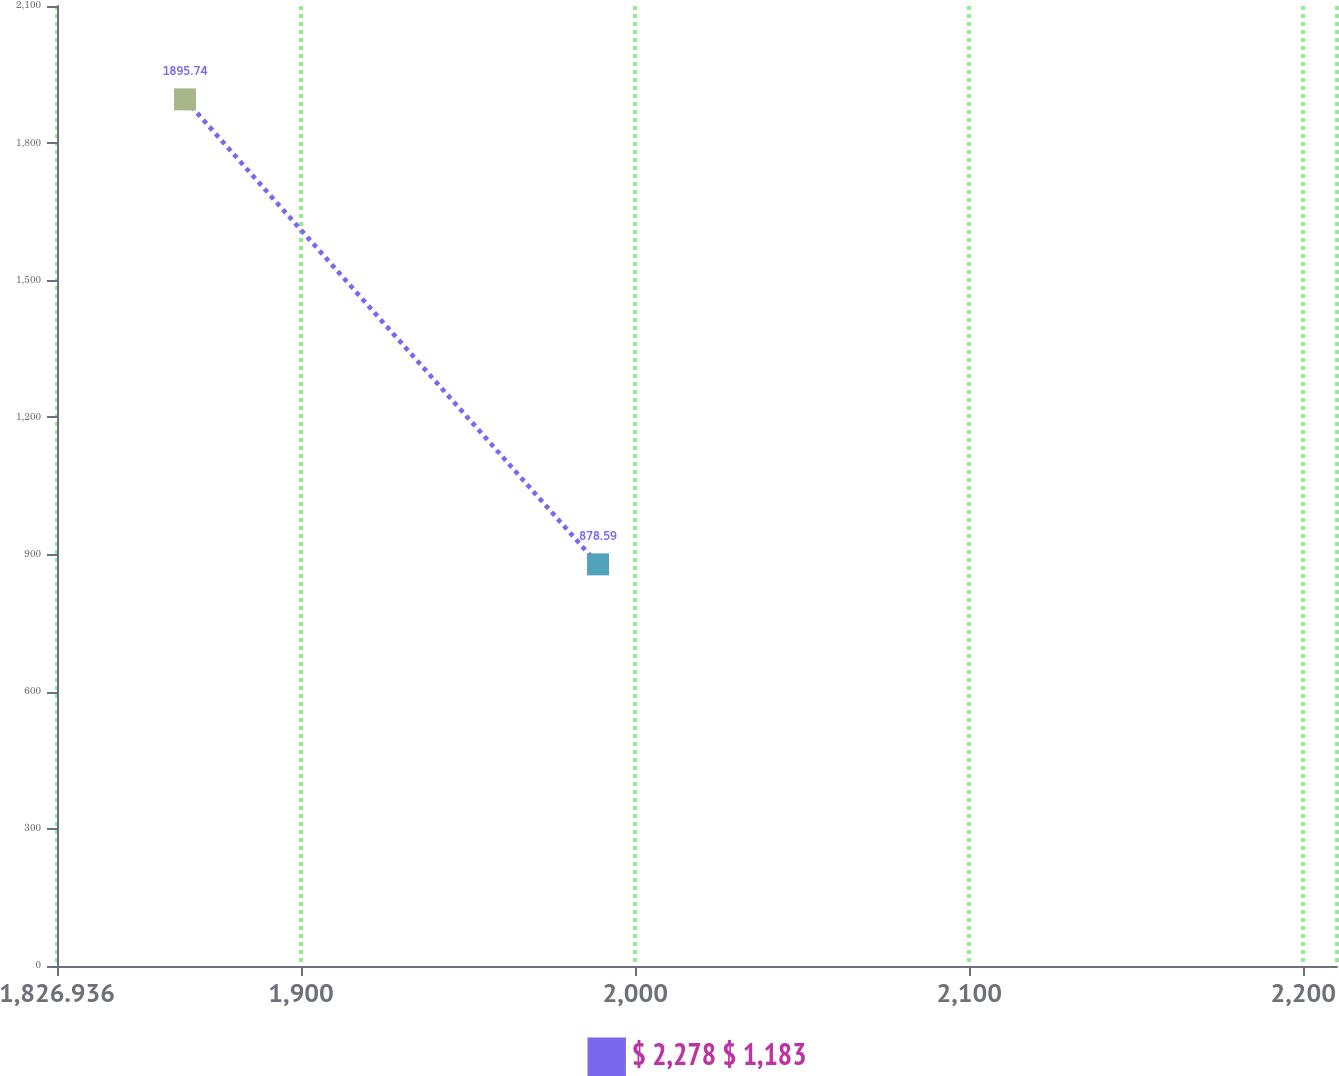<chart> <loc_0><loc_0><loc_500><loc_500><line_chart><ecel><fcel>$ 2,278 $ 1,183<nl><fcel>1865.25<fcel>1895.74<nl><fcel>1988.89<fcel>878.59<nl><fcel>2248.39<fcel>4457.54<nl></chart> 